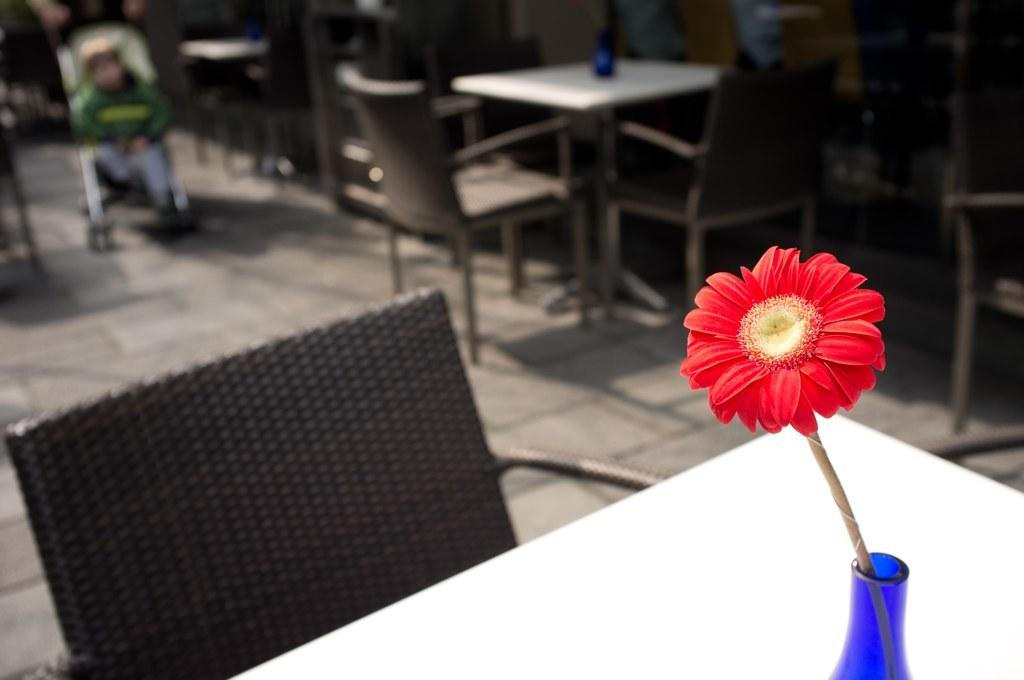What type of flower is in the image? A: There is a red color flower in the image. What color is the table on which the flower is placed? The flower is on a white color table. What can be seen in the background of the image? There are chairs and tables in the background of the image. How is the background of the image depicted? The background of the image is blurred. Where is the cannon located in the image? There is no cannon present in the image. How many screws can be seen holding the table together in the image? The image does not show any screws, as it focuses on the flower and the table's color. Is there a sheep grazing in the background of the image? There is no sheep present in the image; it only features chairs and tables in the background. 